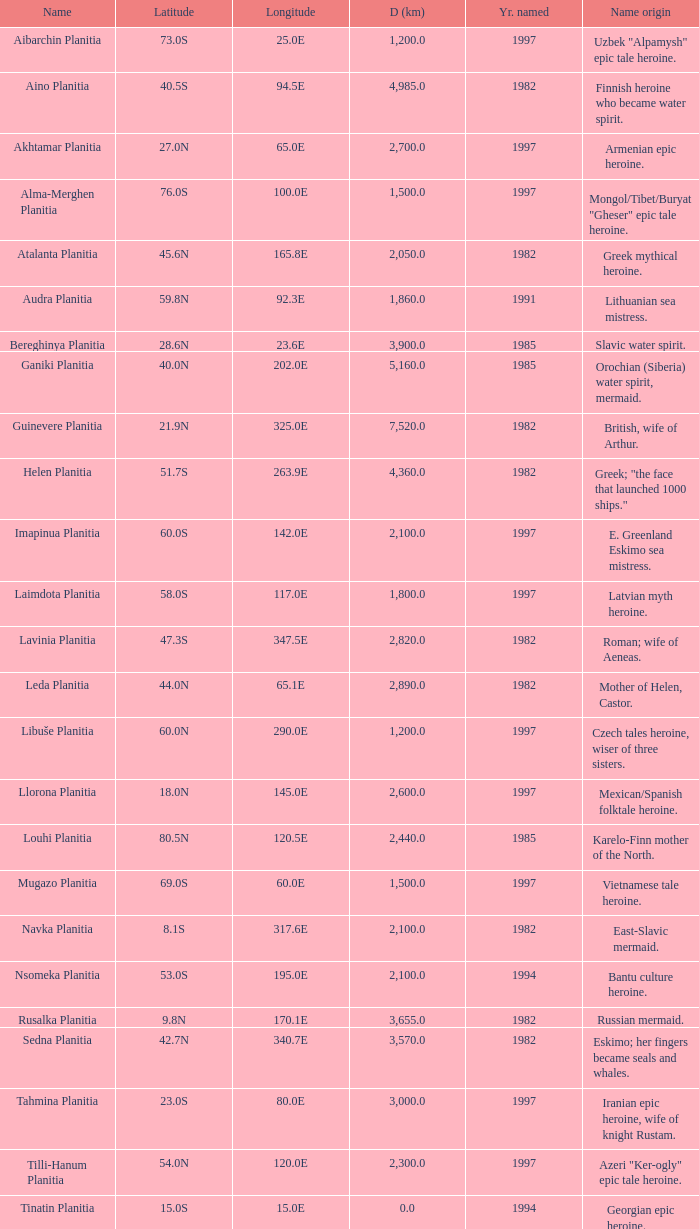Would you be able to parse every entry in this table? {'header': ['Name', 'Latitude', 'Longitude', 'D (km)', 'Yr. named', 'Name origin'], 'rows': [['Aibarchin Planitia', '73.0S', '25.0E', '1,200.0', '1997', 'Uzbek "Alpamysh" epic tale heroine.'], ['Aino Planitia', '40.5S', '94.5E', '4,985.0', '1982', 'Finnish heroine who became water spirit.'], ['Akhtamar Planitia', '27.0N', '65.0E', '2,700.0', '1997', 'Armenian epic heroine.'], ['Alma-Merghen Planitia', '76.0S', '100.0E', '1,500.0', '1997', 'Mongol/Tibet/Buryat "Gheser" epic tale heroine.'], ['Atalanta Planitia', '45.6N', '165.8E', '2,050.0', '1982', 'Greek mythical heroine.'], ['Audra Planitia', '59.8N', '92.3E', '1,860.0', '1991', 'Lithuanian sea mistress.'], ['Bereghinya Planitia', '28.6N', '23.6E', '3,900.0', '1985', 'Slavic water spirit.'], ['Ganiki Planitia', '40.0N', '202.0E', '5,160.0', '1985', 'Orochian (Siberia) water spirit, mermaid.'], ['Guinevere Planitia', '21.9N', '325.0E', '7,520.0', '1982', 'British, wife of Arthur.'], ['Helen Planitia', '51.7S', '263.9E', '4,360.0', '1982', 'Greek; "the face that launched 1000 ships."'], ['Imapinua Planitia', '60.0S', '142.0E', '2,100.0', '1997', 'E. Greenland Eskimo sea mistress.'], ['Laimdota Planitia', '58.0S', '117.0E', '1,800.0', '1997', 'Latvian myth heroine.'], ['Lavinia Planitia', '47.3S', '347.5E', '2,820.0', '1982', 'Roman; wife of Aeneas.'], ['Leda Planitia', '44.0N', '65.1E', '2,890.0', '1982', 'Mother of Helen, Castor.'], ['Libuše Planitia', '60.0N', '290.0E', '1,200.0', '1997', 'Czech tales heroine, wiser of three sisters.'], ['Llorona Planitia', '18.0N', '145.0E', '2,600.0', '1997', 'Mexican/Spanish folktale heroine.'], ['Louhi Planitia', '80.5N', '120.5E', '2,440.0', '1985', 'Karelo-Finn mother of the North.'], ['Mugazo Planitia', '69.0S', '60.0E', '1,500.0', '1997', 'Vietnamese tale heroine.'], ['Navka Planitia', '8.1S', '317.6E', '2,100.0', '1982', 'East-Slavic mermaid.'], ['Nsomeka Planitia', '53.0S', '195.0E', '2,100.0', '1994', 'Bantu culture heroine.'], ['Rusalka Planitia', '9.8N', '170.1E', '3,655.0', '1982', 'Russian mermaid.'], ['Sedna Planitia', '42.7N', '340.7E', '3,570.0', '1982', 'Eskimo; her fingers became seals and whales.'], ['Tahmina Planitia', '23.0S', '80.0E', '3,000.0', '1997', 'Iranian epic heroine, wife of knight Rustam.'], ['Tilli-Hanum Planitia', '54.0N', '120.0E', '2,300.0', '1997', 'Azeri "Ker-ogly" epic tale heroine.'], ['Tinatin Planitia', '15.0S', '15.0E', '0.0', '1994', 'Georgian epic heroine.'], ['Undine Planitia', '13.0N', '303.0E', '2,800.0', '1997', 'Lithuanian water nymph, mermaid.'], ['Vellamo Planitia', '45.4N', '149.1E', '2,155.0', '1985', 'Karelo-Finn mermaid.']]} What is the latitude of the feature of longitude 80.0e 23.0S. 